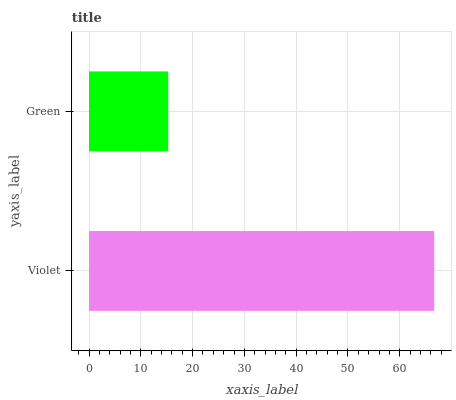Is Green the minimum?
Answer yes or no. Yes. Is Violet the maximum?
Answer yes or no. Yes. Is Green the maximum?
Answer yes or no. No. Is Violet greater than Green?
Answer yes or no. Yes. Is Green less than Violet?
Answer yes or no. Yes. Is Green greater than Violet?
Answer yes or no. No. Is Violet less than Green?
Answer yes or no. No. Is Violet the high median?
Answer yes or no. Yes. Is Green the low median?
Answer yes or no. Yes. Is Green the high median?
Answer yes or no. No. Is Violet the low median?
Answer yes or no. No. 